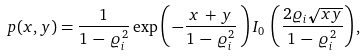<formula> <loc_0><loc_0><loc_500><loc_500>p ( x , y ) = \frac { 1 } { 1 \, - \, \varrho _ { i } ^ { 2 } } \exp \left ( \, - \frac { x \, + \, y } { 1 \, - \, \varrho _ { i } ^ { 2 } } \, \right ) I _ { 0 } \, \left ( \frac { 2 \varrho _ { i } \sqrt { x y } } { 1 \, - \, \varrho _ { i } ^ { 2 } } \right ) ,</formula> 